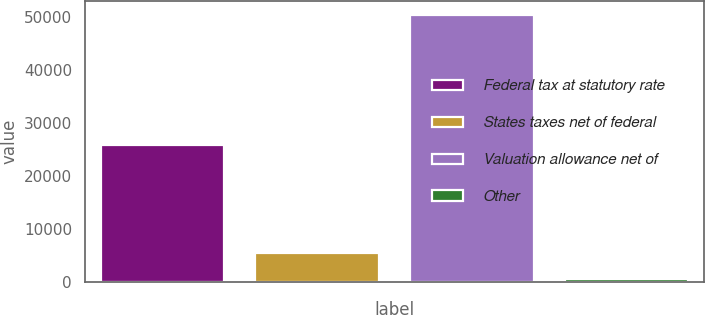<chart> <loc_0><loc_0><loc_500><loc_500><bar_chart><fcel>Federal tax at statutory rate<fcel>States taxes net of federal<fcel>Valuation allowance net of<fcel>Other<nl><fcel>25832<fcel>5495.9<fcel>50360<fcel>511<nl></chart> 